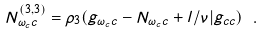Convert formula to latex. <formula><loc_0><loc_0><loc_500><loc_500>N _ { \omega _ { c } c } ^ { ( 3 , 3 ) } = \rho _ { 3 } ( g _ { \omega _ { c } c } - N _ { \omega _ { c } c } + l / \nu | g _ { c c } ) \ .</formula> 